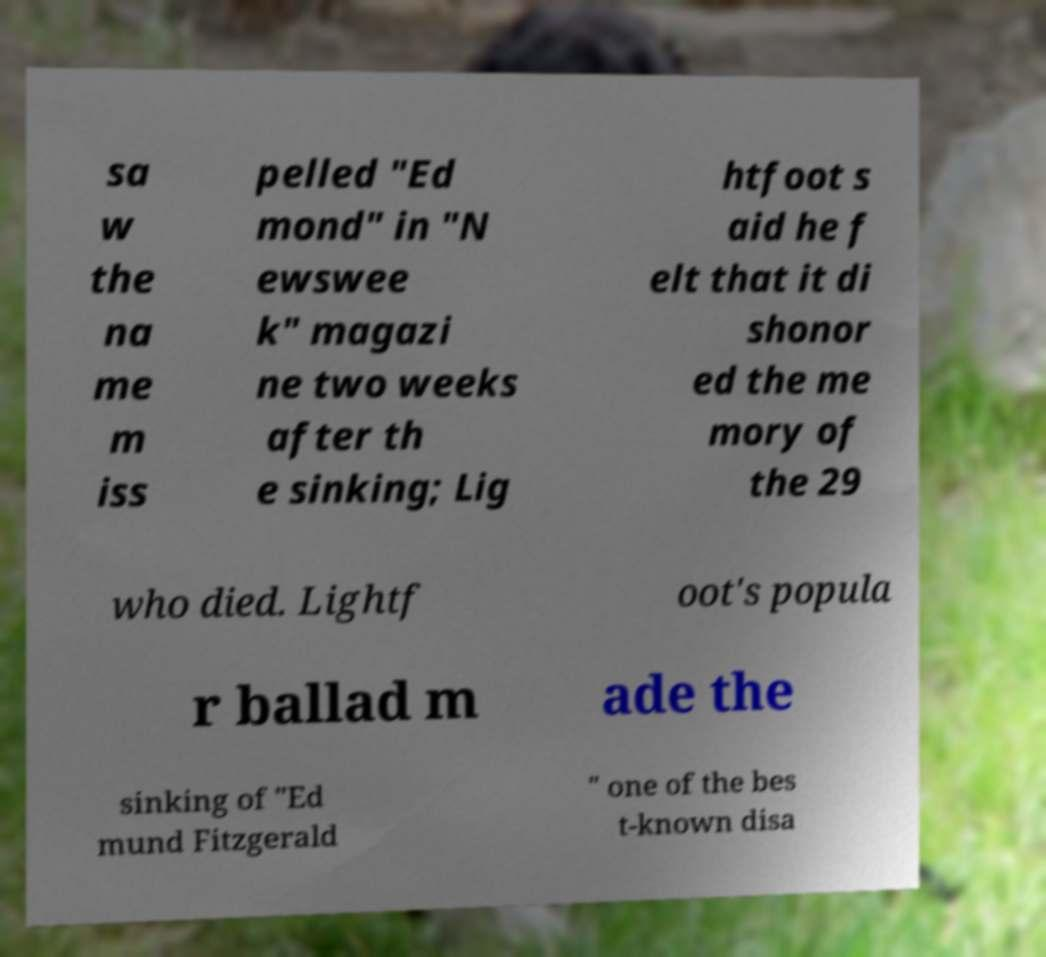Please read and relay the text visible in this image. What does it say? sa w the na me m iss pelled "Ed mond" in "N ewswee k" magazi ne two weeks after th e sinking; Lig htfoot s aid he f elt that it di shonor ed the me mory of the 29 who died. Lightf oot's popula r ballad m ade the sinking of "Ed mund Fitzgerald " one of the bes t-known disa 